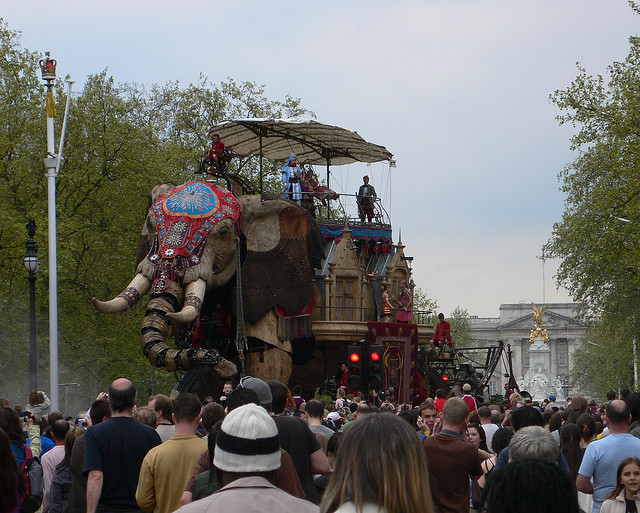<image>What ethnicity is the man on the elephant? The ethnicity of the man on the elephant is ambiguous. It can be Indian, Caucasian, or African. What road are they on? I am not sure what road they are on. It could be in India, Main Street, or even Constitution Hill or a dirt road. What ethnicity is the man on the elephant? I am not sure about the ethnicity of the man on the elephant. It can be seen Indian, Caucasian, or African. What road are they on? I don't know what road they are on. It can be 'india', 'main street', 'constitution hill' or 'dirt'. 